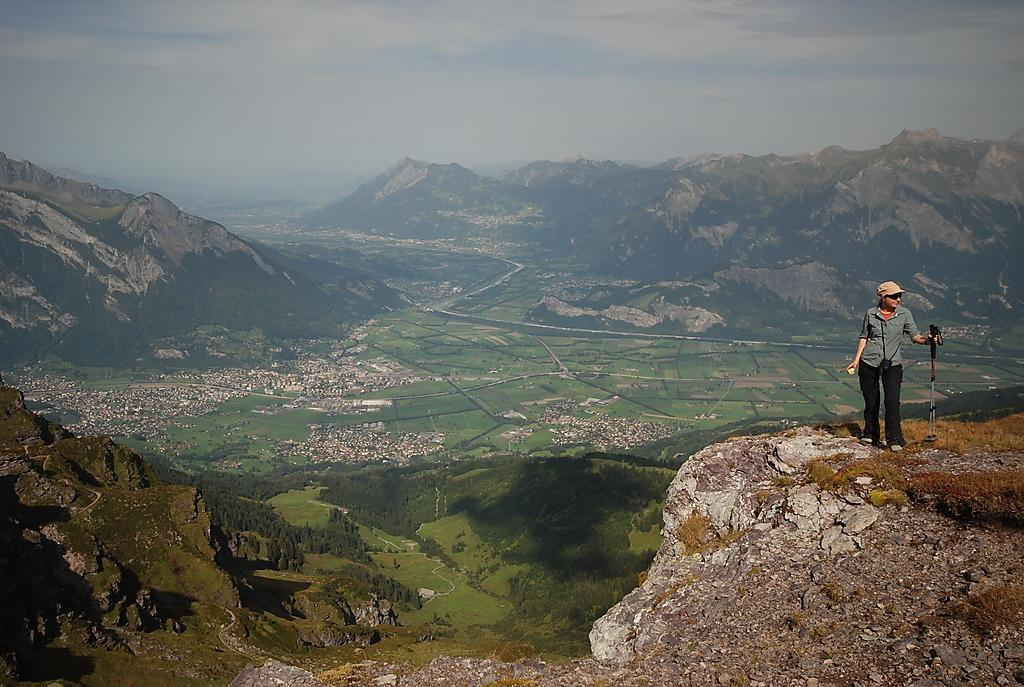What is the main subject in the foreground of the picture? There is a woman in the foreground of the picture. What is the woman doing in the image? The woman is standing on a rock and holding a tripod stand. What can be seen in the background of the image? There are mountains, a city, trees, a path, and the sky visible in the background of the image. What is the condition of the sky in the image? The sky is visible in the background of the image, and there are clouds present. What type of book is the woman reading while standing on the rock? There is no book present in the image, and the woman is not reading anything. 